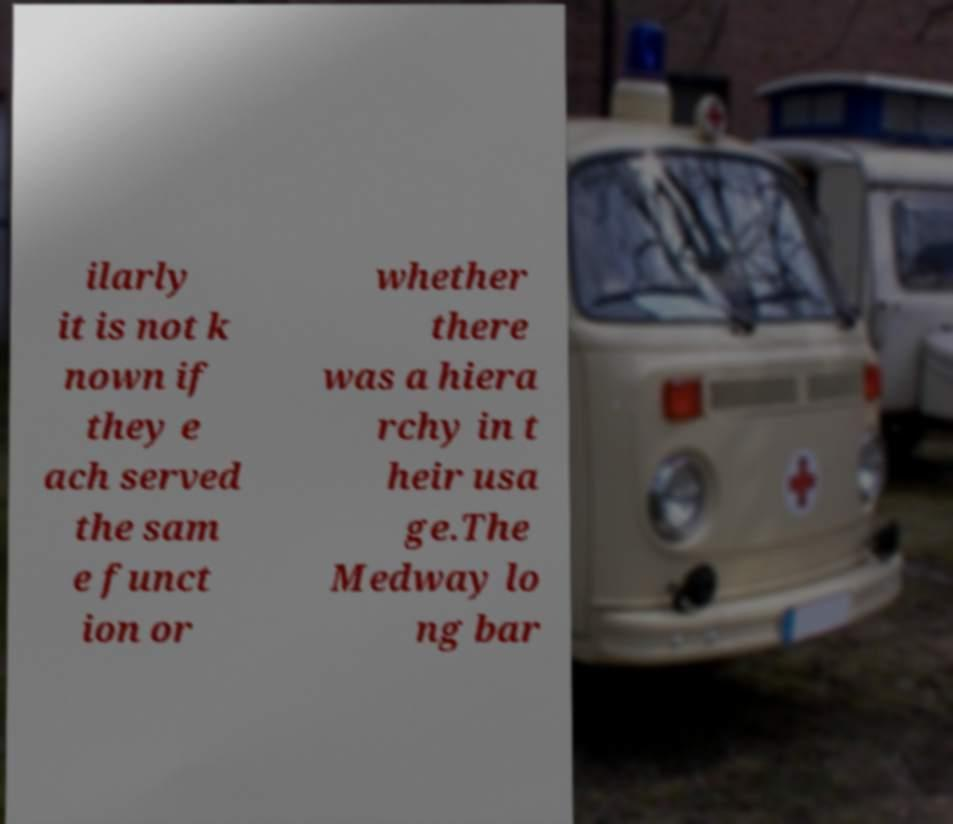What messages or text are displayed in this image? I need them in a readable, typed format. ilarly it is not k nown if they e ach served the sam e funct ion or whether there was a hiera rchy in t heir usa ge.The Medway lo ng bar 